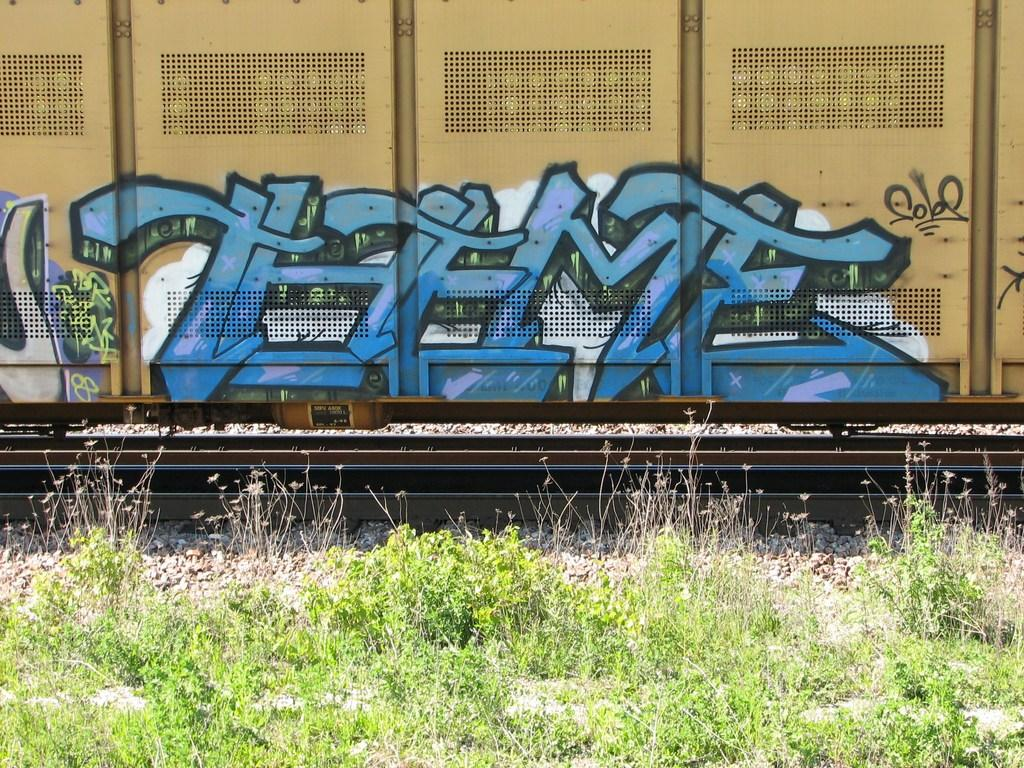<image>
Provide a brief description of the given image. Blue graffiti on the side of a train that says THEME. 